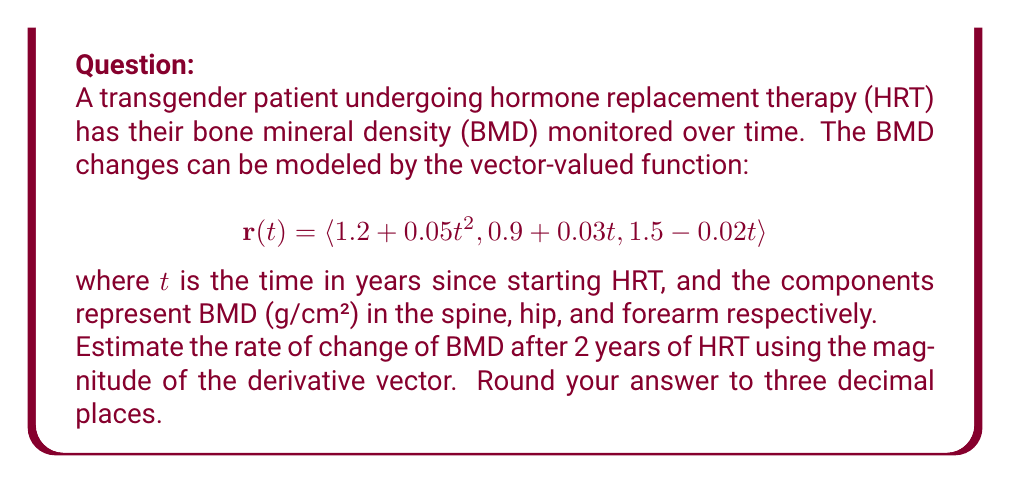Solve this math problem. To solve this problem, we'll follow these steps:

1) First, we need to find the derivative vector $\mathbf{r}'(t)$:

   $$\mathbf{r}'(t) = \langle \frac{d}{dt}(1.2 + 0.05t^2), \frac{d}{dt}(0.9 + 0.03t), \frac{d}{dt}(1.5 - 0.02t) \rangle$$
   $$\mathbf{r}'(t) = \langle 0.1t, 0.03, -0.02 \rangle$$

2) Now, we need to evaluate this at $t = 2$ years:

   $$\mathbf{r}'(2) = \langle 0.1(2), 0.03, -0.02 \rangle = \langle 0.2, 0.03, -0.02 \rangle$$

3) To find the magnitude of this vector, we use the formula:

   $$\|\mathbf{r}'(2)\| = \sqrt{(0.2)^2 + (0.03)^2 + (-0.02)^2}$$

4) Let's calculate this:

   $$\|\mathbf{r}'(2)\| = \sqrt{0.04 + 0.0009 + 0.0004}$$
   $$= \sqrt{0.0413}$$
   $$\approx 0.203$$

5) Rounding to three decimal places, we get 0.203 g/cm²/year.

This represents the estimated rate of change of BMD after 2 years of HRT, considering changes in all three measured areas (spine, hip, and forearm) simultaneously.
Answer: 0.203 g/cm²/year 